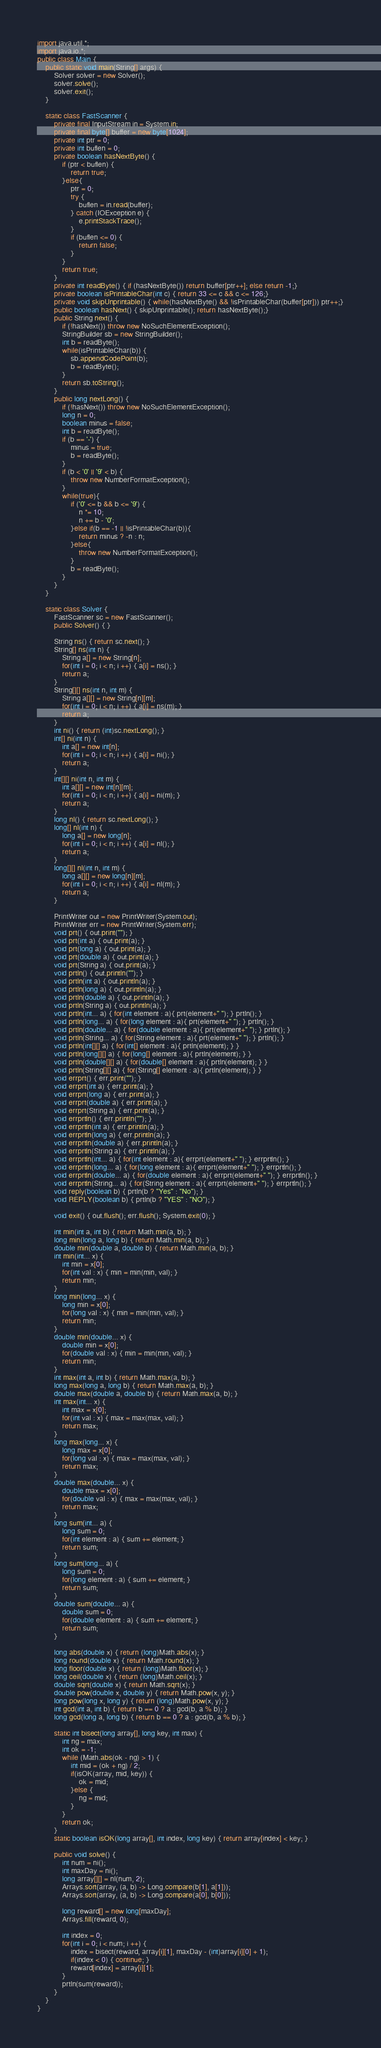Convert code to text. <code><loc_0><loc_0><loc_500><loc_500><_Java_>import java.util.*;
import java.io.*;
public class Main {
	public static void main(String[] args) {
		Solver solver = new Solver();
		solver.solve();
		solver.exit();
	}

	static class FastScanner {
		private final InputStream in = System.in;
		private final byte[] buffer = new byte[1024];
		private int ptr = 0;
		private int buflen = 0;
		private boolean hasNextByte() {
			if (ptr < buflen) {
				return true;
			}else{
				ptr = 0;
				try {
					buflen = in.read(buffer);
				} catch (IOException e) {
					e.printStackTrace();
				}
				if (buflen <= 0) {
					return false;
				}
			}
			return true;
		}
		private int readByte() { if (hasNextByte()) return buffer[ptr++]; else return -1;}
		private boolean isPrintableChar(int c) { return 33 <= c && c <= 126;}
		private void skipUnprintable() { while(hasNextByte() && !isPrintableChar(buffer[ptr])) ptr++;}
		public boolean hasNext() { skipUnprintable(); return hasNextByte();}
		public String next() {
			if (!hasNext()) throw new NoSuchElementException();
			StringBuilder sb = new StringBuilder();
			int b = readByte();
			while(isPrintableChar(b)) {
				sb.appendCodePoint(b);
				b = readByte();
			}
			return sb.toString();
		}
		public long nextLong() {
			if (!hasNext()) throw new NoSuchElementException();
			long n = 0;
			boolean minus = false;
			int b = readByte();
			if (b == '-') {
				minus = true;
				b = readByte();
			}
			if (b < '0' || '9' < b) {
				throw new NumberFormatException();
			}
			while(true){
				if ('0' <= b && b <= '9') {
					n *= 10;
					n += b - '0';
				}else if(b == -1 || !isPrintableChar(b)){
					return minus ? -n : n;
				}else{
					throw new NumberFormatException();
				}
				b = readByte();
			}
		}
	}

	static class Solver {
		FastScanner sc = new FastScanner();
		public Solver() { }

		String ns() { return sc.next(); }
		String[] ns(int n) {
			String a[] = new String[n];
			for(int i = 0; i < n; i ++) { a[i] = ns(); }
			return a;
		}
		String[][] ns(int n, int m) {
			String a[][] = new String[n][m];
			for(int i = 0; i < n; i ++) { a[i] = ns(m); }
			return a;
		}
		int ni() { return (int)sc.nextLong(); }
		int[] ni(int n) {
			int a[] = new int[n];
			for(int i = 0; i < n; i ++) { a[i] = ni(); }
			return a;
		}
		int[][] ni(int n, int m) {
			int a[][] = new int[n][m];
			for(int i = 0; i < n; i ++) { a[i] = ni(m); }
			return a;
		}
		long nl() { return sc.nextLong(); }
		long[] nl(int n) {
			long a[] = new long[n];
			for(int i = 0; i < n; i ++) { a[i] = nl(); }
			return a;
		}
		long[][] nl(int n, int m) {
			long a[][] = new long[n][m];
			for(int i = 0; i < n; i ++) { a[i] = nl(m); }
			return a;
		}

		PrintWriter out = new PrintWriter(System.out);
		PrintWriter err = new PrintWriter(System.err);
		void prt() { out.print(""); }
		void prt(int a) { out.print(a); }
		void prt(long a) { out.print(a); }
		void prt(double a) { out.print(a); }
		void prt(String a) { out.print(a); }
		void prtln() { out.println(""); }
		void prtln(int a) { out.println(a); }
		void prtln(long a) { out.println(a); }
		void prtln(double a) { out.println(a); }
		void prtln(String a) { out.println(a); }
		void prtln(int... a) { for(int element : a){ prt(element+" "); } prtln(); }
		void prtln(long... a) { for(long element : a){ prt(element+" "); } prtln(); }
		void prtln(double... a) { for(double element : a){ prt(element+" "); } prtln(); }
		void prtln(String... a) { for(String element : a){ prt(element+" "); } prtln(); }
		void prtln(int[][] a) { for(int[] element : a){ prtln(element); } }
		void prtln(long[][] a) { for(long[] element : a){ prtln(element); } }
		void prtln(double[][] a) { for(double[] element : a){ prtln(element); } }
		void prtln(String[][] a) { for(String[] element : a){ prtln(element); } }
		void errprt() { err.print(""); }
		void errprt(int a) { err.print(a); }
		void errprt(long a) { err.print(a); }
		void errprt(double a) { err.print(a); }
		void errprt(String a) { err.print(a); }
		void errprtln() { err.println(""); }
		void errprtln(int a) { err.println(a); }
		void errprtln(long a) { err.println(a); }
		void errprtln(double a) { err.println(a); }
		void errprtln(String a) { err.println(a); }
		void errprtln(int... a) { for(int element : a){ errprt(element+" "); } errprtln(); }
		void errprtln(long... a) { for(long element : a){ errprt(element+" "); } errprtln(); }
		void errprtln(double... a) { for(double element : a){ errprt(element+" "); } errprtln(); }
		void errprtln(String... a) { for(String element : a){ errprt(element+" "); } errprtln(); }
		void reply(boolean b) { prtln(b ? "Yes" : "No"); }
		void REPLY(boolean b) { prtln(b ? "YES" : "NO"); }

		void exit() { out.flush(); err.flush(); System.exit(0); }

		int min(int a, int b) { return Math.min(a, b); }
		long min(long a, long b) { return Math.min(a, b); }
		double min(double a, double b) { return Math.min(a, b); }
		int min(int... x) {
			int min = x[0];
			for(int val : x) { min = min(min, val); }
			return min;
		}
		long min(long... x) {
			long min = x[0];
			for(long val : x) { min = min(min, val); }
			return min;
		}
		double min(double... x) {
			double min = x[0];
			for(double val : x) { min = min(min, val); }
			return min;
		}
		int max(int a, int b) { return Math.max(a, b); }
		long max(long a, long b) { return Math.max(a, b); }
		double max(double a, double b) { return Math.max(a, b); }
		int max(int... x) {
			int max = x[0];
			for(int val : x) { max = max(max, val); }
			return max;
		}
		long max(long... x) {
			long max = x[0];
			for(long val : x) { max = max(max, val); }
			return max;
		}
		double max(double... x) {
			double max = x[0];
			for(double val : x) { max = max(max, val); }
			return max;
		}
		long sum(int... a) {
			long sum = 0;
			for(int element : a) { sum += element; }
			return sum;
		}
		long sum(long... a) {
			long sum = 0;
			for(long element : a) { sum += element; }
			return sum;
		}
		double sum(double... a) {
			double sum = 0;
			for(double element : a) { sum += element; }
			return sum;
		}

		long abs(double x) { return (long)Math.abs(x); }
		long round(double x) { return Math.round(x); }
		long floor(double x) { return (long)Math.floor(x); }
		long ceil(double x) { return (long)Math.ceil(x); }
		double sqrt(double x) { return Math.sqrt(x); }
		double pow(double x, double y) { return Math.pow(x, y); }
		long pow(long x, long y) { return (long)Math.pow(x, y); }
		int gcd(int a, int b) { return b == 0 ? a : gcd(b, a % b); }
		long gcd(long a, long b) { return b == 0 ? a : gcd(b, a % b); }

		static int bisect(long array[], long key, int max) {
			int ng = max;
			int ok = -1;
			while (Math.abs(ok - ng) > 1) {
				int mid = (ok + ng) / 2;
				if(isOK(array, mid, key)) {
					ok = mid;
				}else {
					ng = mid;
				}
			}
			return ok;
		}
		static boolean isOK(long array[], int index, long key) { return array[index] < key; }

		public void solve() {
			int num = ni();
			int maxDay = ni();
			long array[][] = nl(num, 2);
			Arrays.sort(array, (a, b) -> Long.compare(b[1], a[1]));
			Arrays.sort(array, (a, b) -> Long.compare(a[0], b[0]));

			long reward[] = new long[maxDay];
			Arrays.fill(reward, 0);

			int index = 0;
			for(int i = 0; i < num; i ++) {
				index = bisect(reward, array[i][1], maxDay - (int)array[i][0] + 1);
				if(index < 0) { continue; }
				reward[index] = array[i][1];
			}
			prtln(sum(reward));
		}
	}
}</code> 